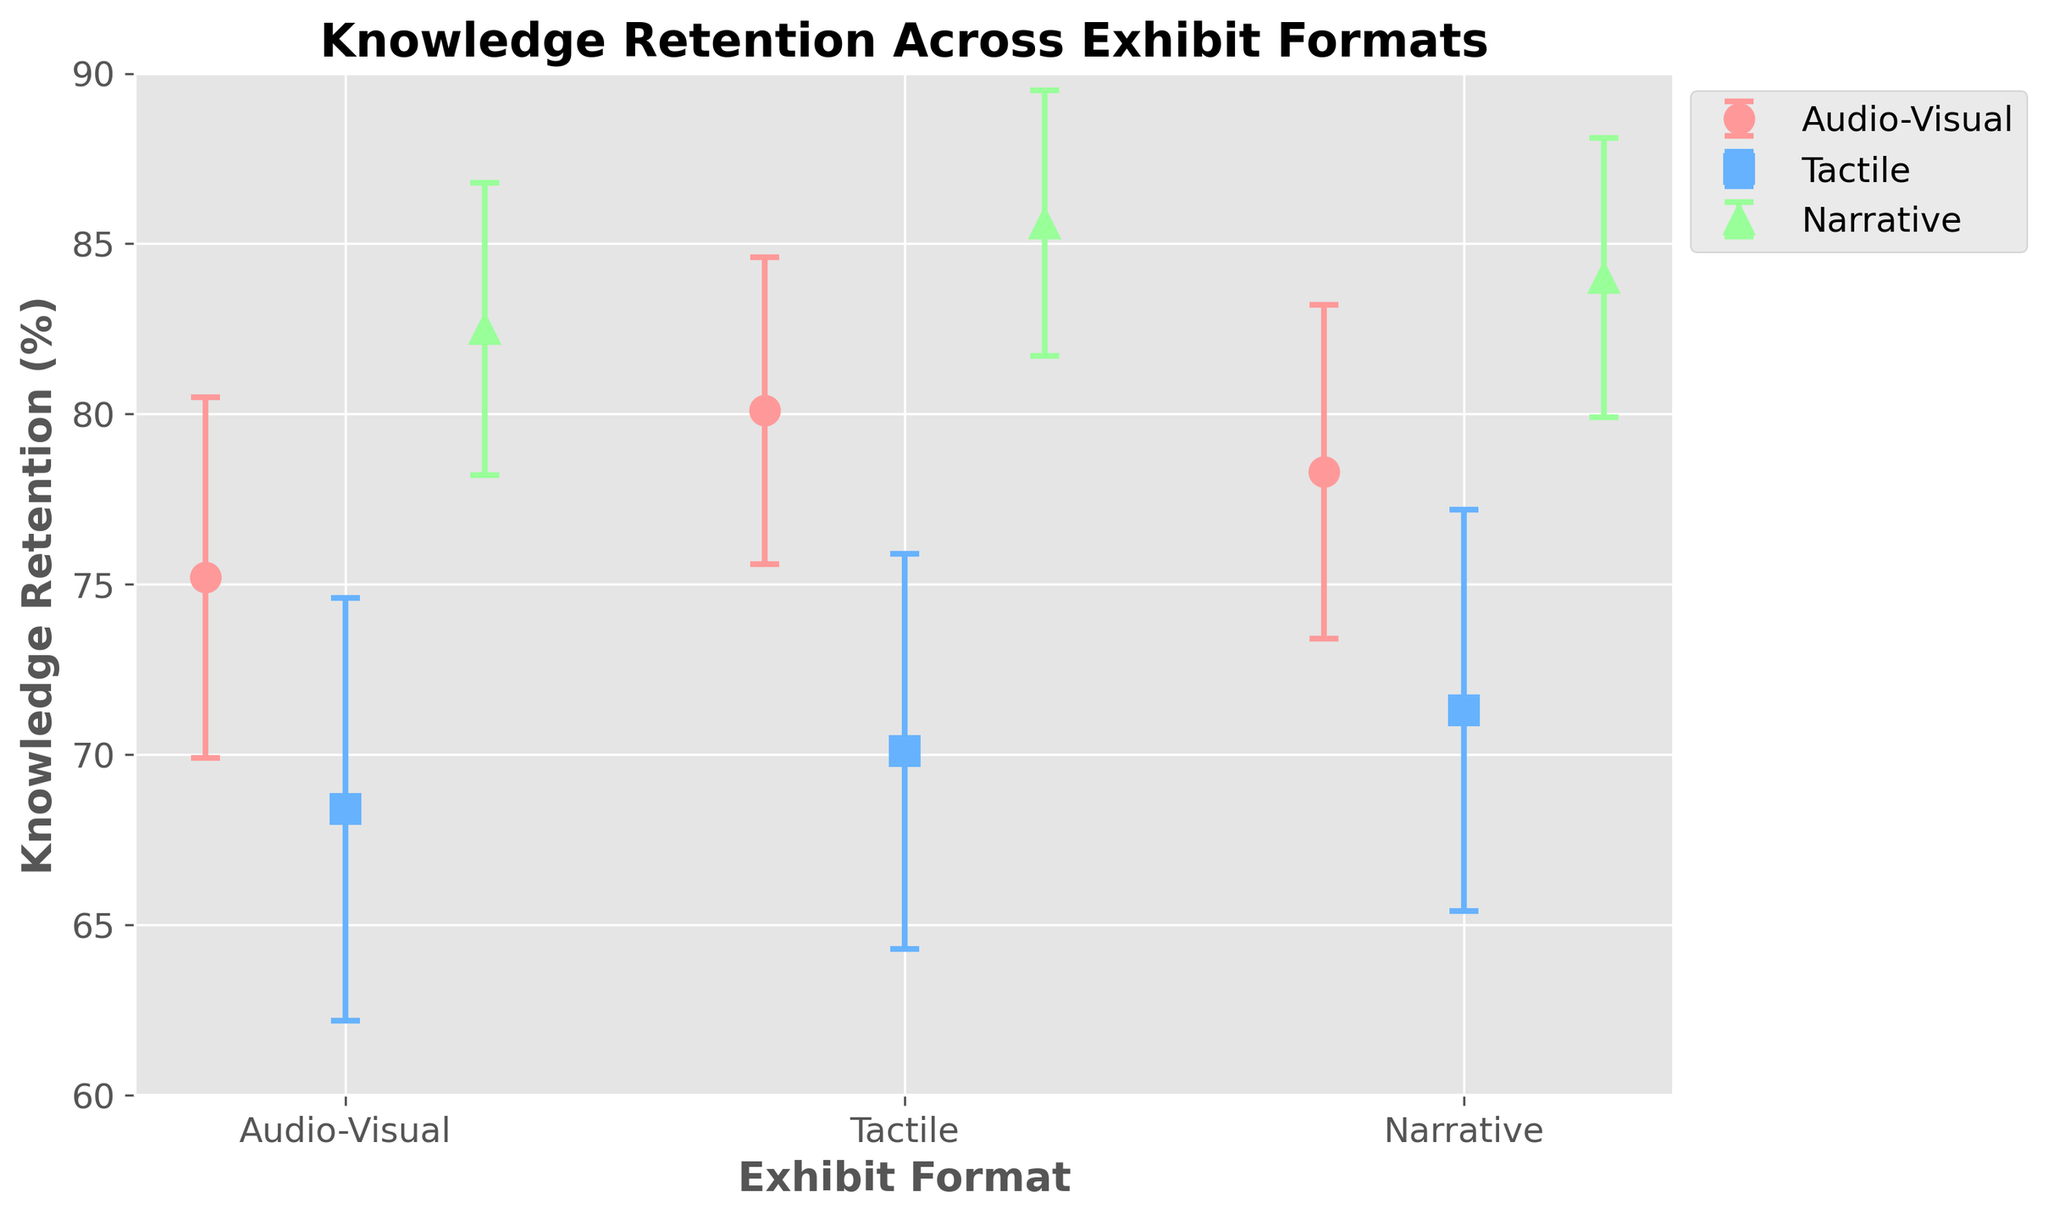What is the title of the figure? The title of the figure is typically located at the top and summarized in a clear descriptive sentence, which helps to understand the content and purpose of the figure.
Answer: Knowledge Retention Across Exhibit Formats What is the mean retention for the Audio-Visual exhibit format? To find the mean retention for the Audio-Visual exhibit format, observe the points on the error bars corresponding to Audio-Visual and identify their mean value.
Answer: 77.87 Which exhibit format has the highest mean retention? To find the exhibit format with the highest mean retention, compare the mean values of all exhibit formats and identify the largest one.
Answer: Narrative How does the mean retention of the Narrative format compare to that of the Tactile format? Compare the mean retention of the Narrative format (which is the highest among all formats) to the mean retention of the Tactile format by observing their relative positions on the y-axis.
Answer: Higher What is the range of the mean retention values for the Tactile exhibit format? To determine the range of mean retention values for the Tactile format, subtract the minimum mean retention value from the maximum mean retention value within the Tactile points.
Answer: 2.9 (71.3 - 68.4) Which exhibit format has the highest standard error, and what is its value? To find the exhibit format with the highest standard error, compare the error bars' lengths for all formats. The format with the longest error bar has the highest standard error.
Answer: Tactile, 6.2 Out of all the exhibit formats, which one shows the least variation in knowledge retention, and how can you tell? The exhibit format with the smallest error bars indicates the least variation in knowledge retention. Observe which error bars are the shortest across all formats.
Answer: Narrative What are the average mean retention values for all the exhibit formats combined? To find this, sum the mean retention values for all data points across all exhibit formats, and then divide by the total number of data points. 
For Audio-Visual: (75.2 + 80.1 + 78.3)/3 = 77.87
For Tactile: (68.4 + 70.1 + 71.3)/3 = 69.93
For Narrative: (82.5 + 85.6 + 84.0)/3 = 84.03
Total Average: (77.87 + 69.93 + 84.03)/3
Answer: 77.28 Between the Audio-Visual and Narrative formats, which one has the greater maximum mean retention, and what is the value? Compare the highest mean retention values within the Audio-Visual and Narrative formats.
Answer: Narrative, 85.6 